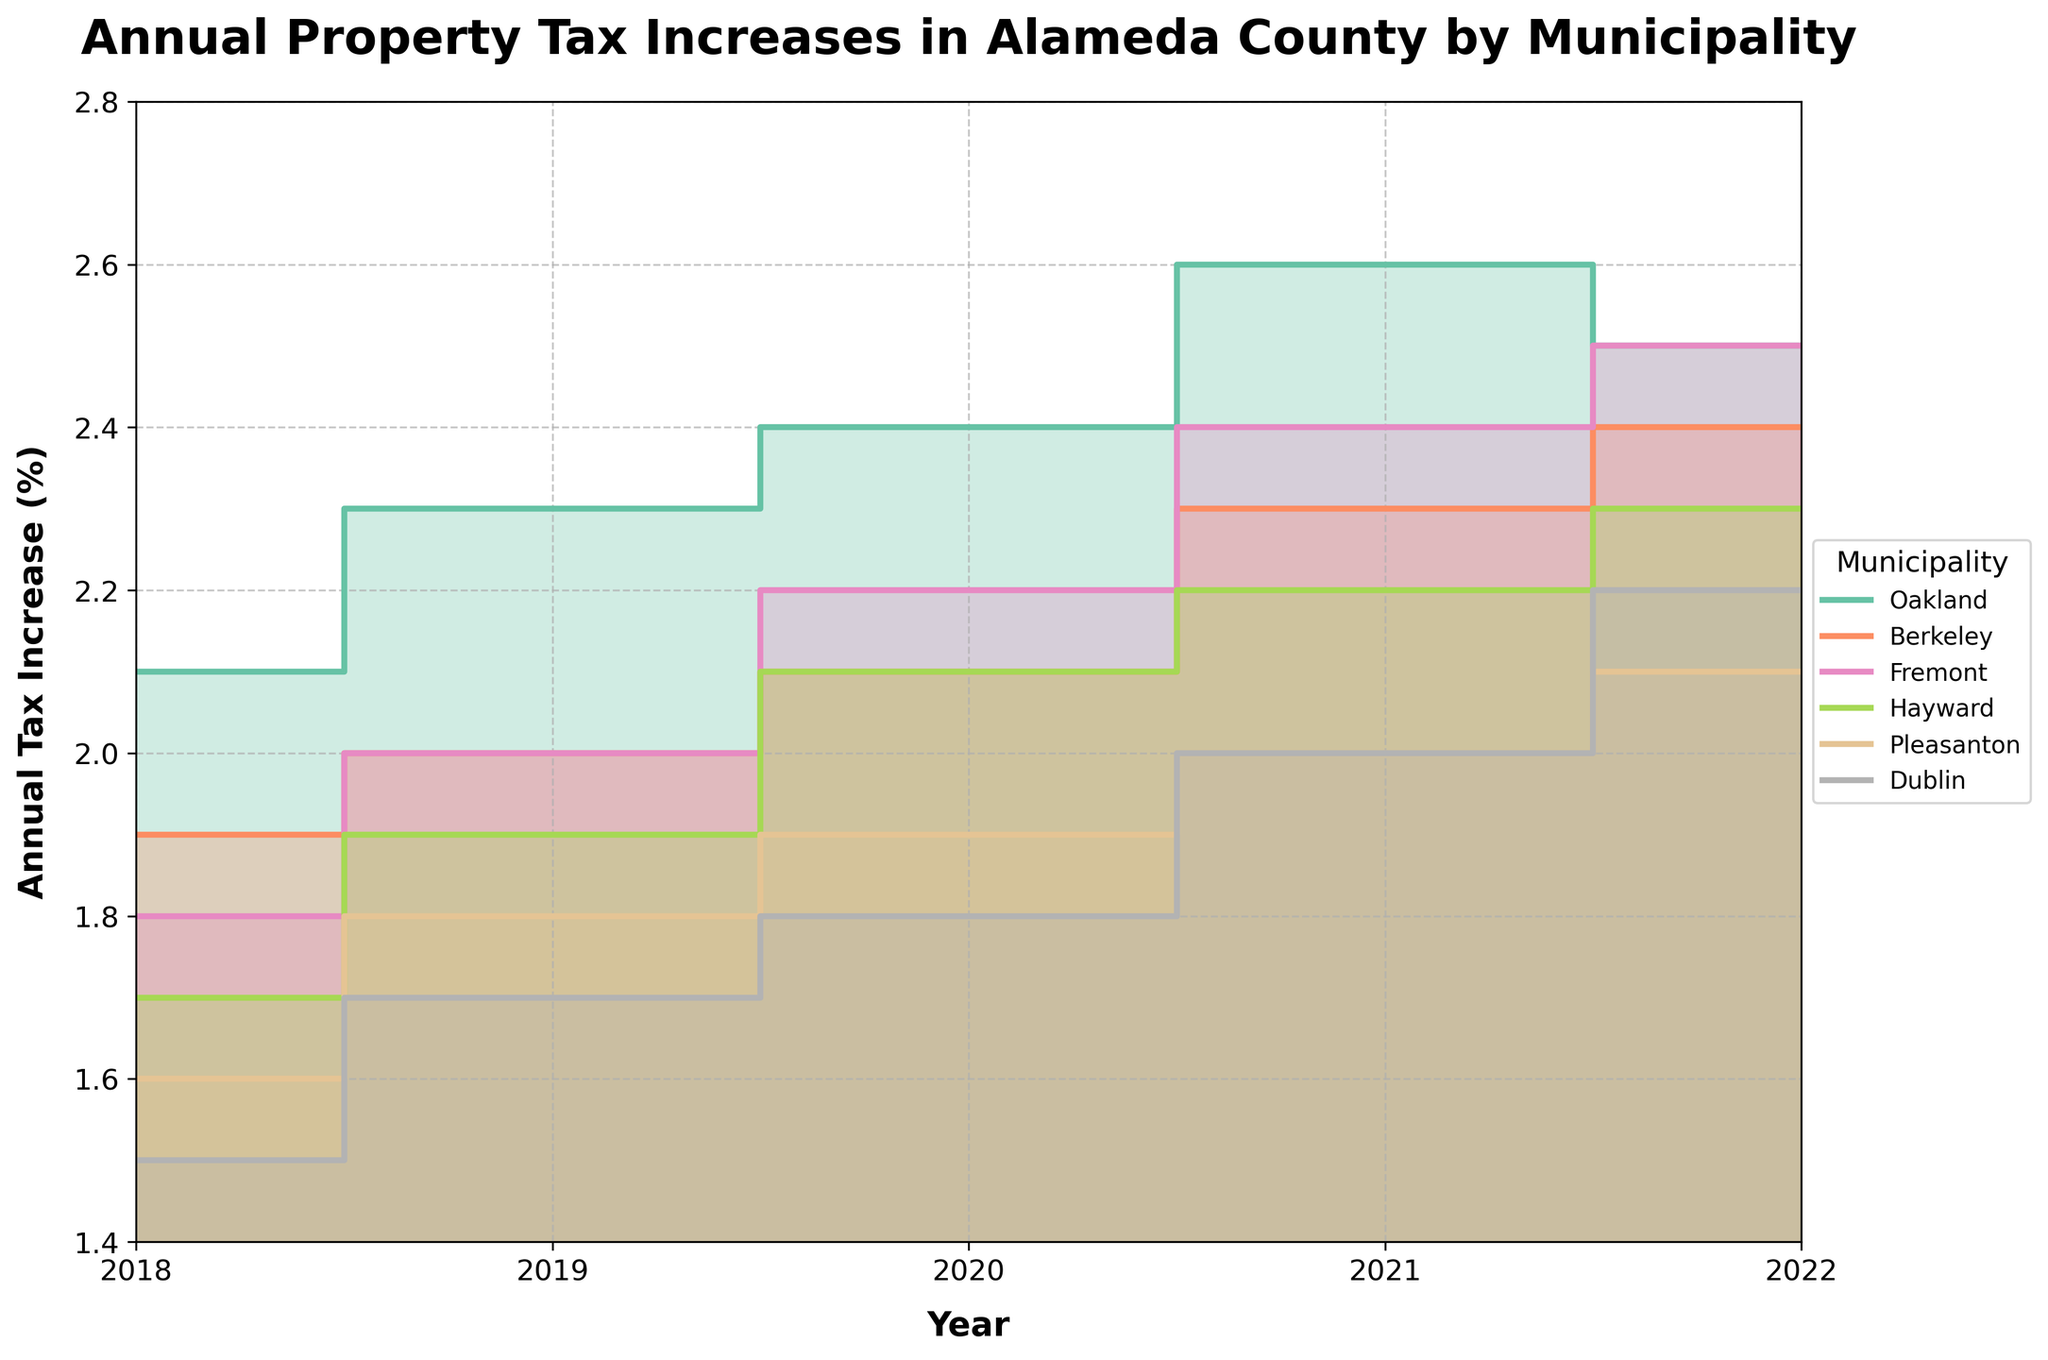what is the title of the figure? The title of the figure is displayed prominently at the top. By observing the visual information, the title reads: "Annual Property Tax Increases in Alameda County by Municipality".
Answer: Annual Property Tax Increases in Alameda County by Municipality which municipality had the highest annual property tax increase in 2022? Referring to the data points on the right edge of the step area chart for the year 2022, the highest value among the municipalities is Oakland, which had a tax increase of 2.5%.
Answer: Oakland how much did the annual property tax increase in Dublin change between 2018 and 2022? To find the change, observe the data points for Dublin in 2018 and 2022. The values are 1.5% for 2018 and 2.2% for 2022. The change is calculated as 2.2% - 1.5% = 0.7%.
Answer: 0.7% which municipality experienced the smallest increase in annual property tax between 2018 and 2022? By comparing the values for each municipality in 2018 and 2022, Dublin had the smallest overall increase, moving from 1.5% to 2.2%, making the increase 0.7%.
Answer: Dublin how do the annual property tax increases of Pleasanton and Hayward in 2021 compare? To compare the values for the year 2021, observe the respective data points for Pleasanton and Hayward. Pleasanton has an increase of 2.0% and Hayward has an increase of 2.2%. Hayward had a higher increase.
Answer: Hayward which municipality had a consistent increase in annual property tax each year from 2018 to 2022? Reviewing the steps in the chart, Fremont had a consistent increase each year: 1.8% (2018), 2.0% (2019), 2.2% (2020), 2.4% (2021), and 2.5% (2022).
Answer: Fremont what was the average annual property tax increase for Berkeley from 2018 to 2022? The average is calculated by summing the values from 2018 to 2022 for Berkeley (1.9% + 2.0% + 2.1% + 2.3% + 2.4%) and dividing by 5: (1.9 + 2.0 + 2.1 + 2.3 + 2.4) / 5 = 10.7 / 5 = 2.14%.
Answer: 2.14% which municipalities had their highest annual property tax increase in 2021? By observing the step points, both Oakland (2.6%) and Fremont (2.4%) had their peak increase in 2021.
Answer: Oakland and Fremont compare the annual property tax increase trend of Oakland with that of Pleasanton. Oakland shows a general upward trend with slight fluctuations, starting at 2.1% in 2018 and ending at 2.5% in 2022, peaking in 2021 at 2.6%. Pleasanton shows a steady and slower increase from 1.6% in 2018 to 2.1% in 2022 without fluctuations.
Answer: Oakland has a fluctuating high trend, while Pleasanton has a slow steady increase in which year did Berkeley's annual property tax increase equal that of Fremont? Observing the steps for both Berkeley and Fremont, their increases were equal at 2.0% in 2019.
Answer: 2019 